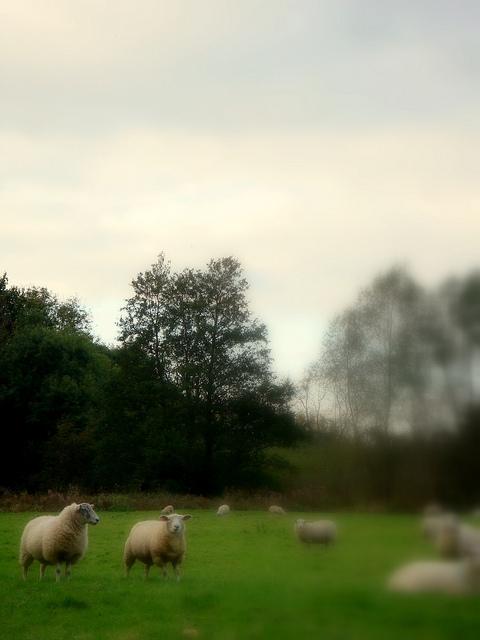Are these animals in captivity?
Give a very brief answer. No. Is the animal smiling?
Give a very brief answer. No. Is this in the countryside?
Be succinct. Yes. How many trees are not in the fog?
Keep it brief. 1. Will the sheep graze here?
Short answer required. Yes. What are most of the sheep next to?
Short answer required. Trees. Are these sheep or dogs?
Keep it brief. Sheep. How many kids are there?
Answer briefly. 0. What are the sheep laying down on?
Write a very short answer. Grass. Is one side of the photo blurry?
Concise answer only. Yes. Are the sheep hungry?
Be succinct. Yes. Is the animal in this picture a mutant?
Quick response, please. No. 